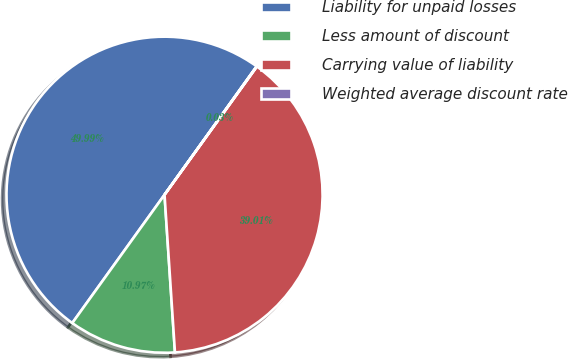<chart> <loc_0><loc_0><loc_500><loc_500><pie_chart><fcel>Liability for unpaid losses<fcel>Less amount of discount<fcel>Carrying value of liability<fcel>Weighted average discount rate<nl><fcel>49.98%<fcel>10.97%<fcel>39.01%<fcel>0.03%<nl></chart> 